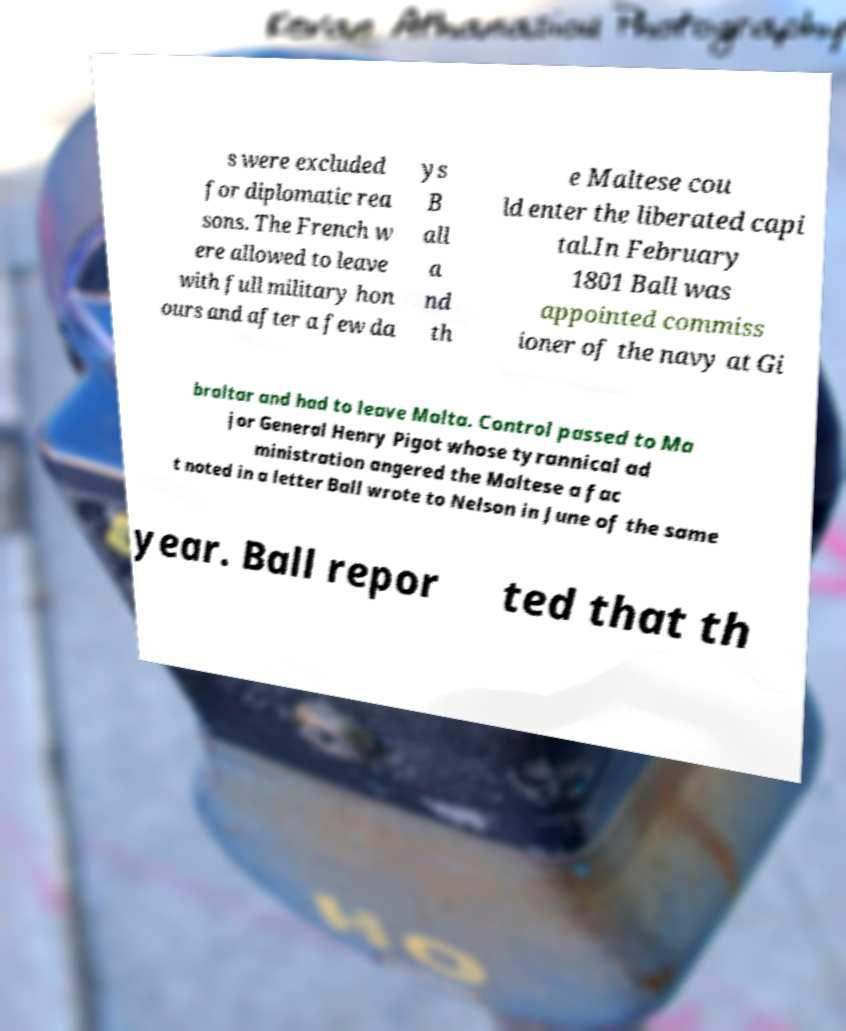Please read and relay the text visible in this image. What does it say? s were excluded for diplomatic rea sons. The French w ere allowed to leave with full military hon ours and after a few da ys B all a nd th e Maltese cou ld enter the liberated capi tal.In February 1801 Ball was appointed commiss ioner of the navy at Gi braltar and had to leave Malta. Control passed to Ma jor General Henry Pigot whose tyrannical ad ministration angered the Maltese a fac t noted in a letter Ball wrote to Nelson in June of the same year. Ball repor ted that th 